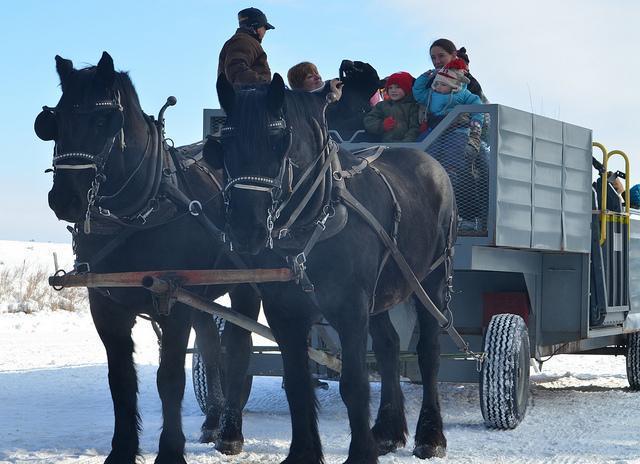How many horses are going to pull this cart?
Give a very brief answer. 2. How many horses are there?
Give a very brief answer. 2. How many people are there?
Give a very brief answer. 4. 